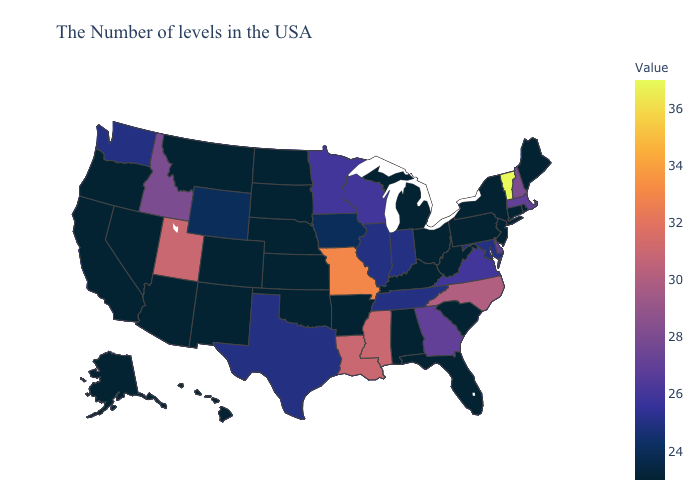Among the states that border West Virginia , does Virginia have the highest value?
Give a very brief answer. Yes. Does Connecticut have the highest value in the USA?
Keep it brief. No. Which states have the lowest value in the USA?
Answer briefly. Maine, Rhode Island, Connecticut, New York, New Jersey, Pennsylvania, South Carolina, West Virginia, Ohio, Florida, Michigan, Kentucky, Alabama, Arkansas, Kansas, Nebraska, Oklahoma, South Dakota, North Dakota, Colorado, New Mexico, Montana, Arizona, Nevada, California, Oregon, Alaska, Hawaii. Which states have the lowest value in the West?
Answer briefly. Colorado, New Mexico, Montana, Arizona, Nevada, California, Oregon, Alaska, Hawaii. Does the map have missing data?
Answer briefly. No. Does the map have missing data?
Short answer required. No. 